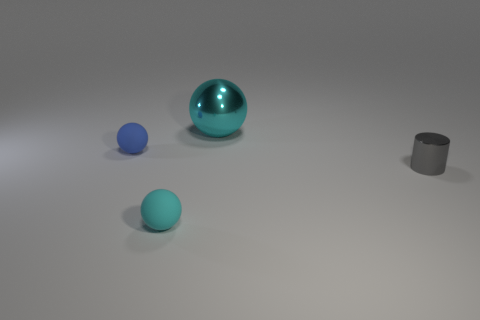Subtract all big metallic balls. How many balls are left? 2 Add 4 large cyan things. How many objects exist? 8 Subtract all blue spheres. How many spheres are left? 2 Subtract all balls. How many objects are left? 1 Subtract 1 spheres. How many spheres are left? 2 Subtract all small brown spheres. Subtract all balls. How many objects are left? 1 Add 2 gray cylinders. How many gray cylinders are left? 3 Add 4 tiny cyan metallic balls. How many tiny cyan metallic balls exist? 4 Subtract 0 yellow cylinders. How many objects are left? 4 Subtract all yellow cylinders. Subtract all cyan cubes. How many cylinders are left? 1 